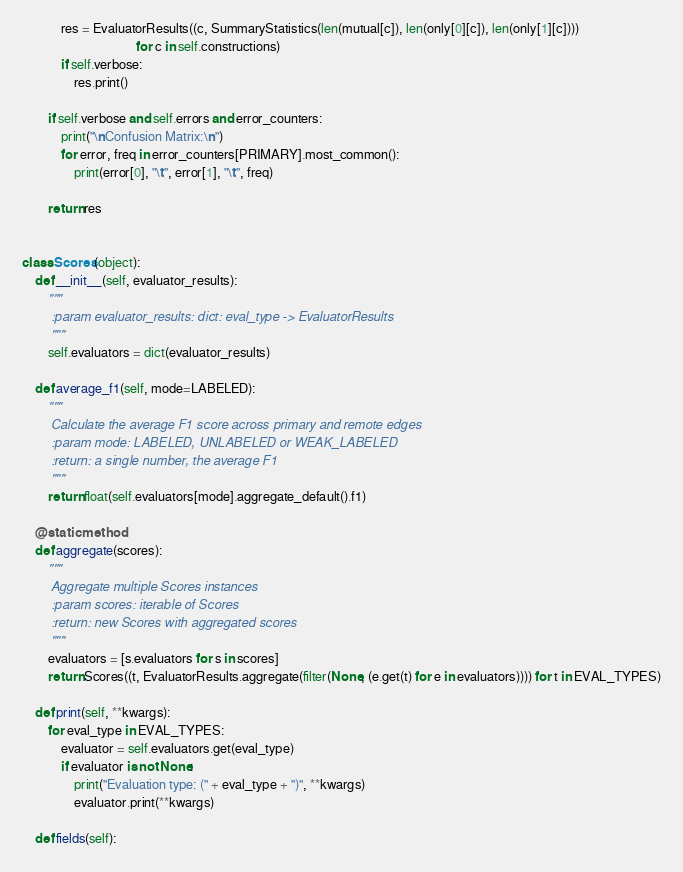Convert code to text. <code><loc_0><loc_0><loc_500><loc_500><_Python_>            res = EvaluatorResults((c, SummaryStatistics(len(mutual[c]), len(only[0][c]), len(only[1][c])))
                                   for c in self.constructions)
            if self.verbose:
                res.print()

        if self.verbose and self.errors and error_counters:
            print("\nConfusion Matrix:\n")
            for error, freq in error_counters[PRIMARY].most_common():
                print(error[0], "\t", error[1], "\t", freq)

        return res


class Scores(object):
    def __init__(self, evaluator_results):
        """
        :param evaluator_results: dict: eval_type -> EvaluatorResults
        """
        self.evaluators = dict(evaluator_results)

    def average_f1(self, mode=LABELED):
        """
        Calculate the average F1 score across primary and remote edges
        :param mode: LABELED, UNLABELED or WEAK_LABELED
        :return: a single number, the average F1
        """
        return float(self.evaluators[mode].aggregate_default().f1)

    @staticmethod
    def aggregate(scores):
        """
        Aggregate multiple Scores instances
        :param scores: iterable of Scores
        :return: new Scores with aggregated scores
        """
        evaluators = [s.evaluators for s in scores]
        return Scores((t, EvaluatorResults.aggregate(filter(None, (e.get(t) for e in evaluators)))) for t in EVAL_TYPES)

    def print(self, **kwargs):
        for eval_type in EVAL_TYPES:
            evaluator = self.evaluators.get(eval_type)
            if evaluator is not None:
                print("Evaluation type: (" + eval_type + ")", **kwargs)
                evaluator.print(**kwargs)

    def fields(self):</code> 